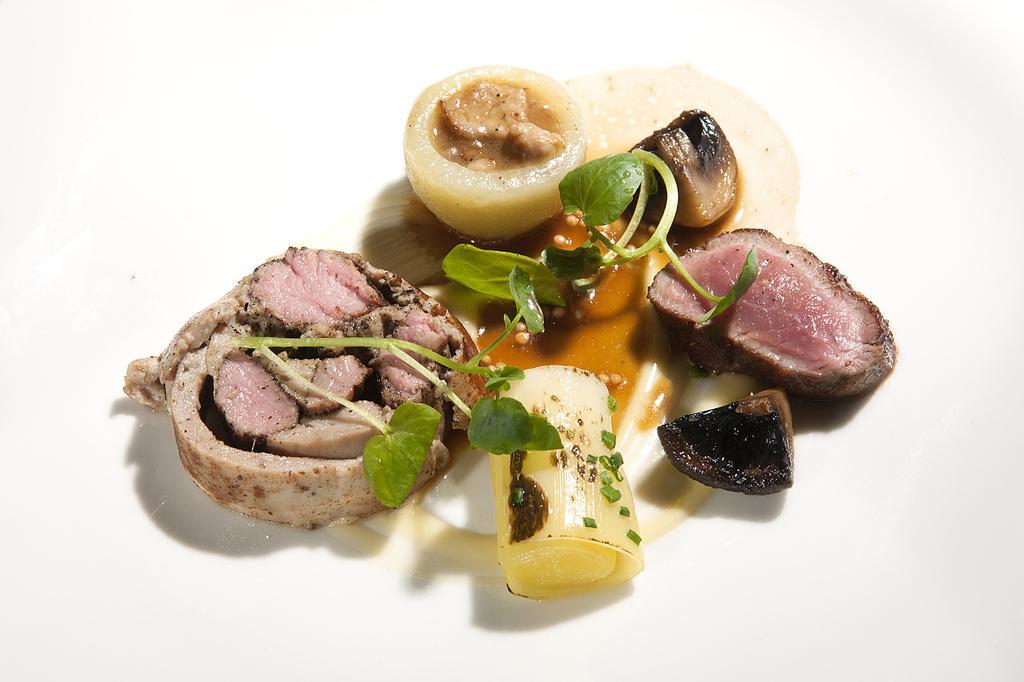How would you summarize this image in a sentence or two? In this picture I can see the white color surface, on which there is food which is of brown, pink, yellow and black color. I can also see few leaves. 